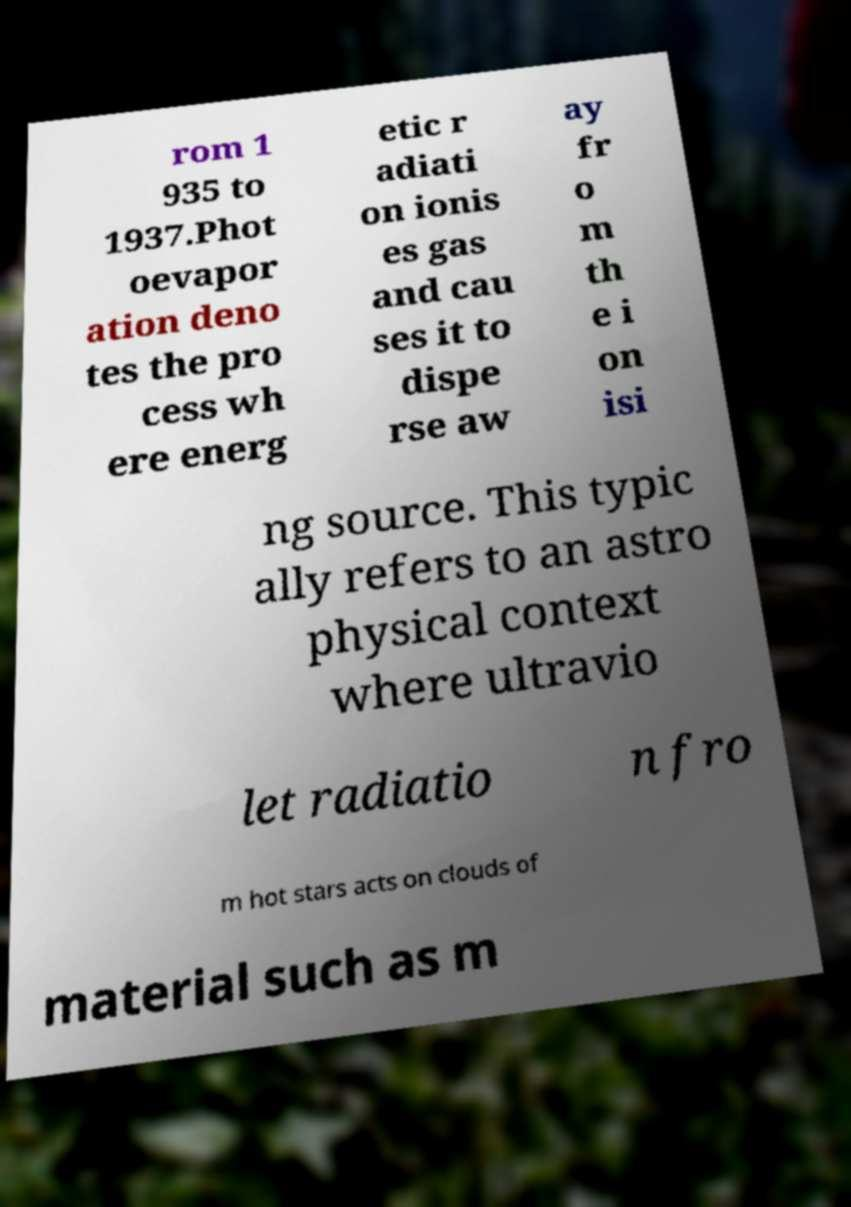Could you extract and type out the text from this image? rom 1 935 to 1937.Phot oevapor ation deno tes the pro cess wh ere energ etic r adiati on ionis es gas and cau ses it to dispe rse aw ay fr o m th e i on isi ng source. This typic ally refers to an astro physical context where ultravio let radiatio n fro m hot stars acts on clouds of material such as m 